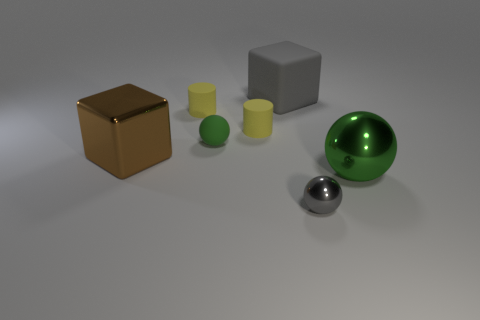Add 2 tiny yellow cylinders. How many objects exist? 9 Subtract all balls. How many objects are left? 4 Subtract all gray rubber balls. Subtract all large green shiny balls. How many objects are left? 6 Add 4 small rubber spheres. How many small rubber spheres are left? 5 Add 3 tiny metallic things. How many tiny metallic things exist? 4 Subtract 0 green cubes. How many objects are left? 7 